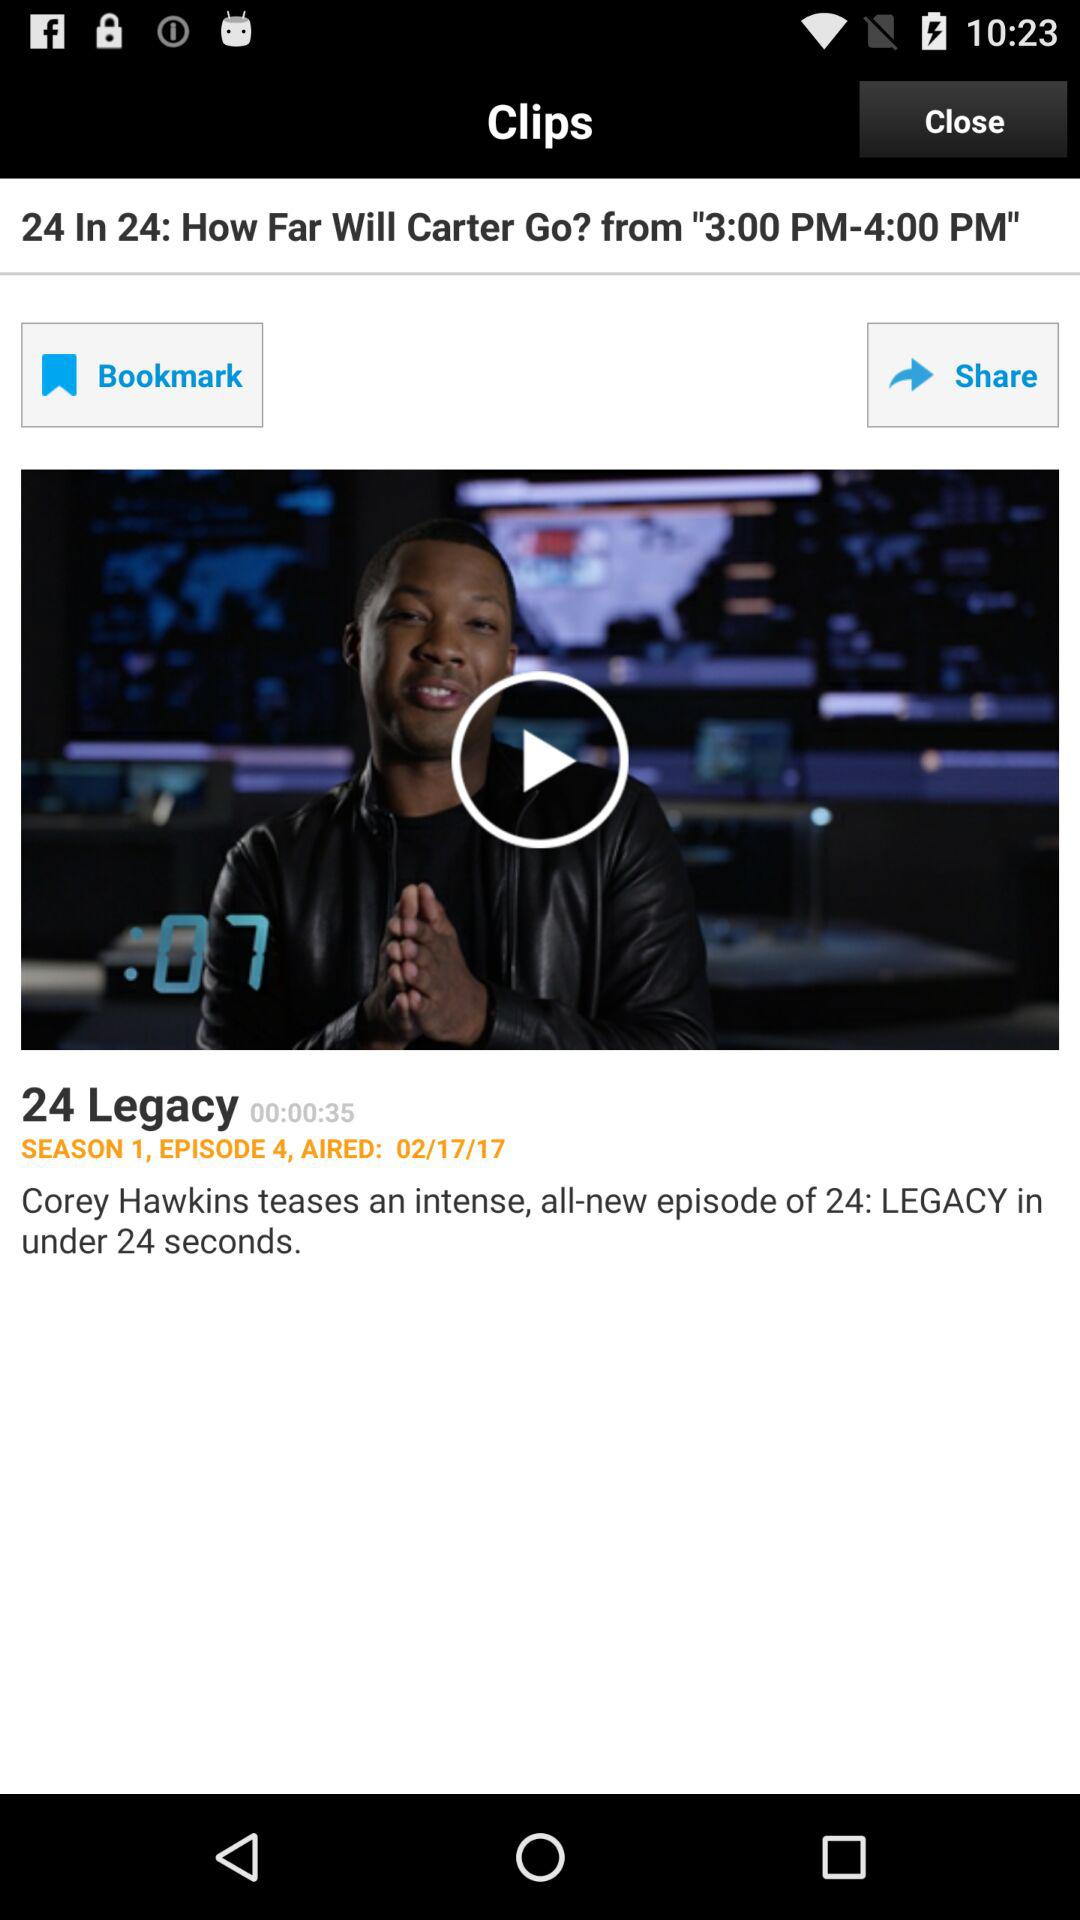How many episodes of 24 Legacy have aired?
Answer the question using a single word or phrase. 4 